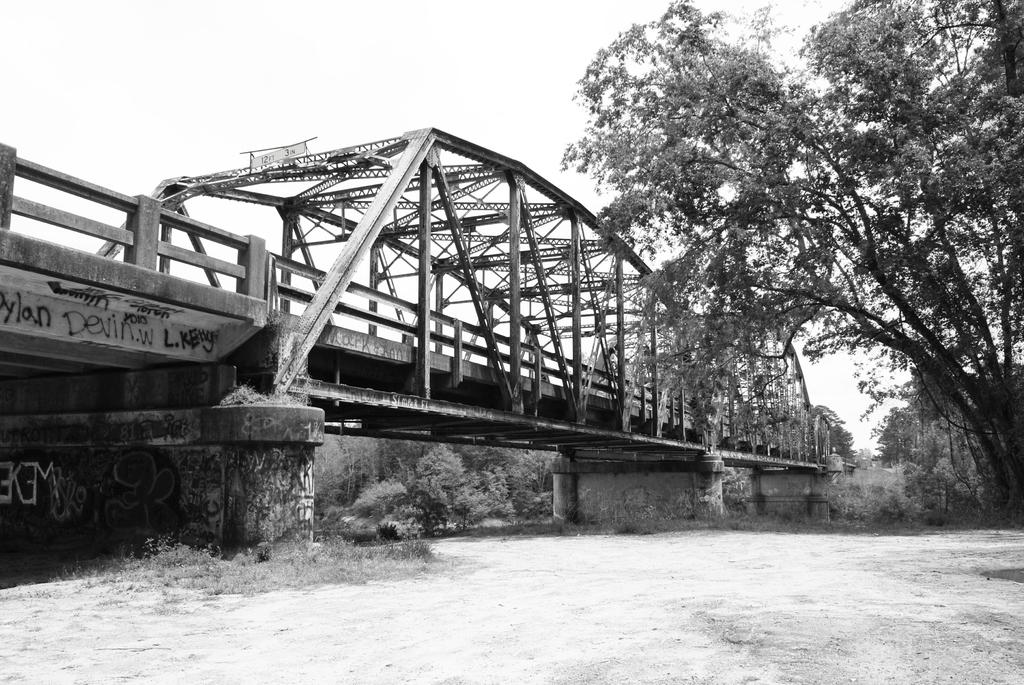What is the color scheme of the image? The image is black and white. What type of terrain can be seen in the image? There is land in the image. What natural element is present in the image? There is a tree in the image. What man-made structure can be seen in the background of the image? There is a bridge in the background of the image. What else can be seen in the background of the image? There are trees in the background of the image. What type of coil is used to support the tree in the image? There is no coil present in the image; the tree is standing on its own. What mass is visible in the image? The image does not depict any specific mass; it shows a tree, land, a bridge, and trees in the background. 